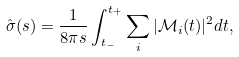<formula> <loc_0><loc_0><loc_500><loc_500>\hat { \sigma } ( s ) = \frac { 1 } { 8 \pi s } \int ^ { t _ { + } } _ { t _ { - } } \sum _ { i } | \mathcal { M } _ { i } ( t ) | ^ { 2 } d t ,</formula> 